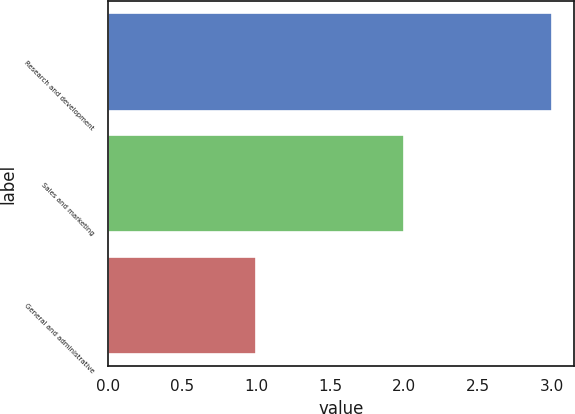Convert chart. <chart><loc_0><loc_0><loc_500><loc_500><bar_chart><fcel>Research and development<fcel>Sales and marketing<fcel>General and administrative<nl><fcel>3<fcel>2<fcel>1<nl></chart> 